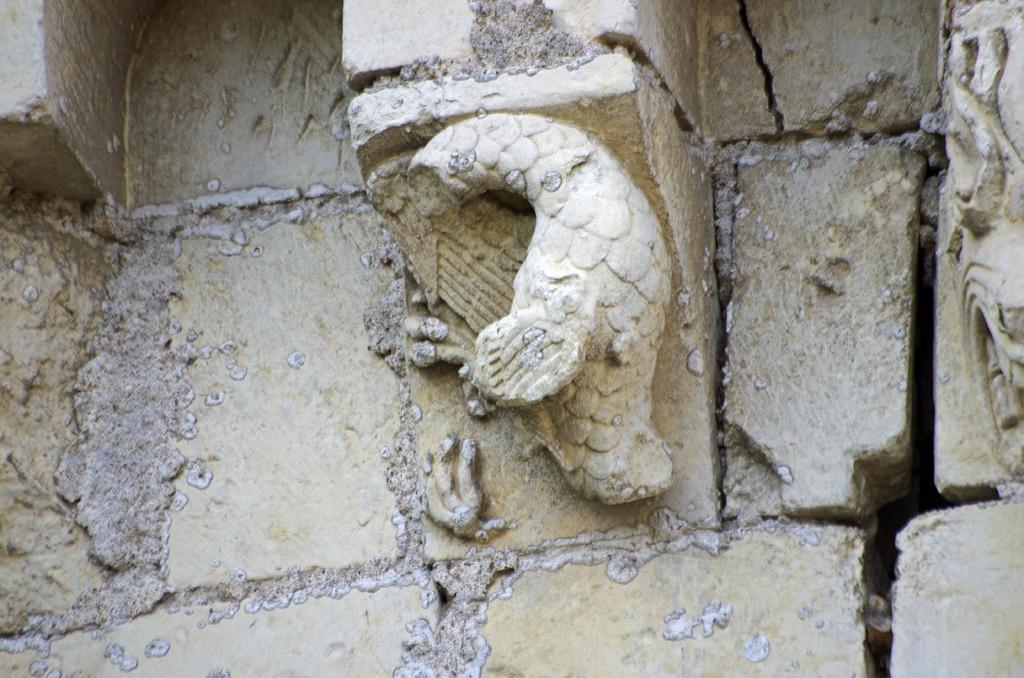What type of structure can be seen in the background of the image? There is a stone wall in the background of the image. What is the main subject in the middle of the image? There is a carved stone in the middle of the image. Reasoning: Let'g: Let's think step by step in order to produce the conversation. We start by identifying the main subjects and objects in the image based on the provided facts. We then formulate questions that focus on the location and characteristics of these subjects and objects, ensuring that each question can be answered definitively with the information given. We avoid yes/no questions and ensure that the language is simple and clear. Absurd Question/Answer: How does the stone wall expand in the image? The stone wall does not expand in the image; it is a static structure in the background. What type of performance is being shown in the image? There is: There is no performance or show depicted in the image; it features a stone wall and a carved stone. How does the stone wall move in the image? The stone wall does not move in the image; it is a stationary structure in the background. What type of dance is being performed by the stone carving in the image? There is no dance or performance depicted in the image; it features a stone wall and a carved stone. 